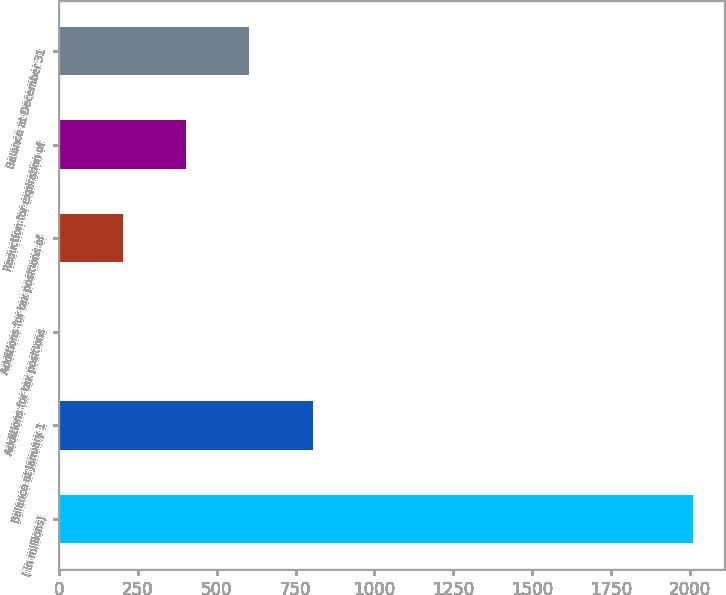<chart> <loc_0><loc_0><loc_500><loc_500><bar_chart><fcel>( in millions)<fcel>Balance at January 1<fcel>Additions for tax positions<fcel>Additions for tax positions of<fcel>Reduction for expiration of<fcel>Balance at December 31<nl><fcel>2010<fcel>804.36<fcel>0.6<fcel>201.54<fcel>402.48<fcel>603.42<nl></chart> 